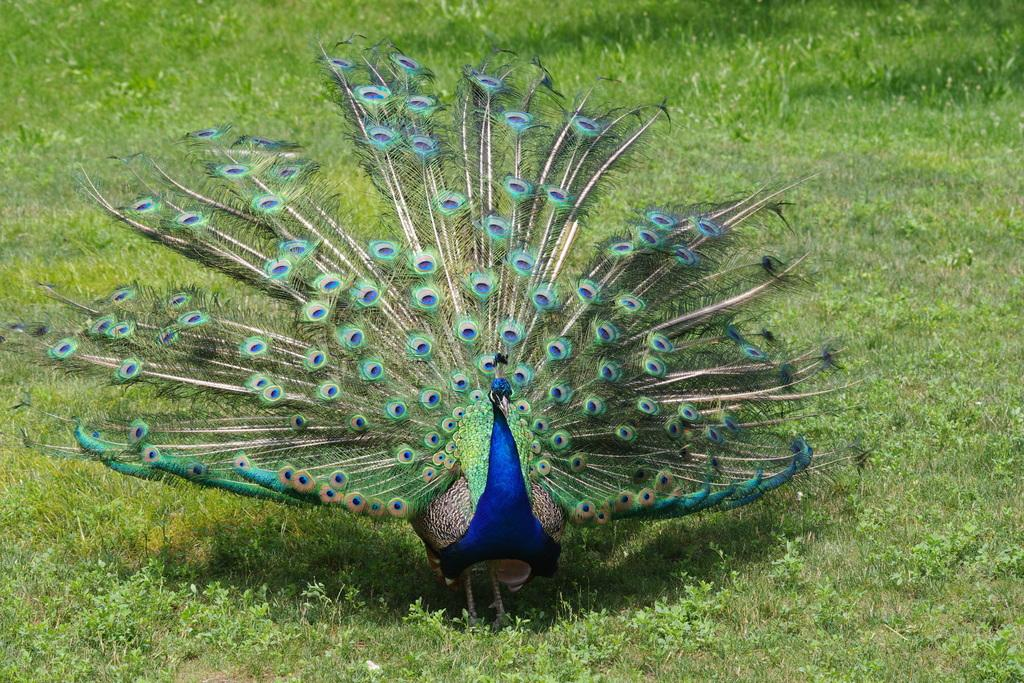What type of animal is in the image? There is a peacock in the image. What can be seen in the background of the image? There is grass and plants in the background of the image. What type of team is visible in the image? There is no team present in the image; it features a peacock and a background with grass and plants. What kind of apparatus can be seen in the image? There is no apparatus present in the image. 